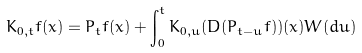<formula> <loc_0><loc_0><loc_500><loc_500>K _ { 0 , t } f ( x ) = P _ { t } f ( x ) + \int _ { 0 } ^ { t } K _ { 0 , u } ( D ( P _ { t - u } f ) ) ( x ) W ( d u )</formula> 